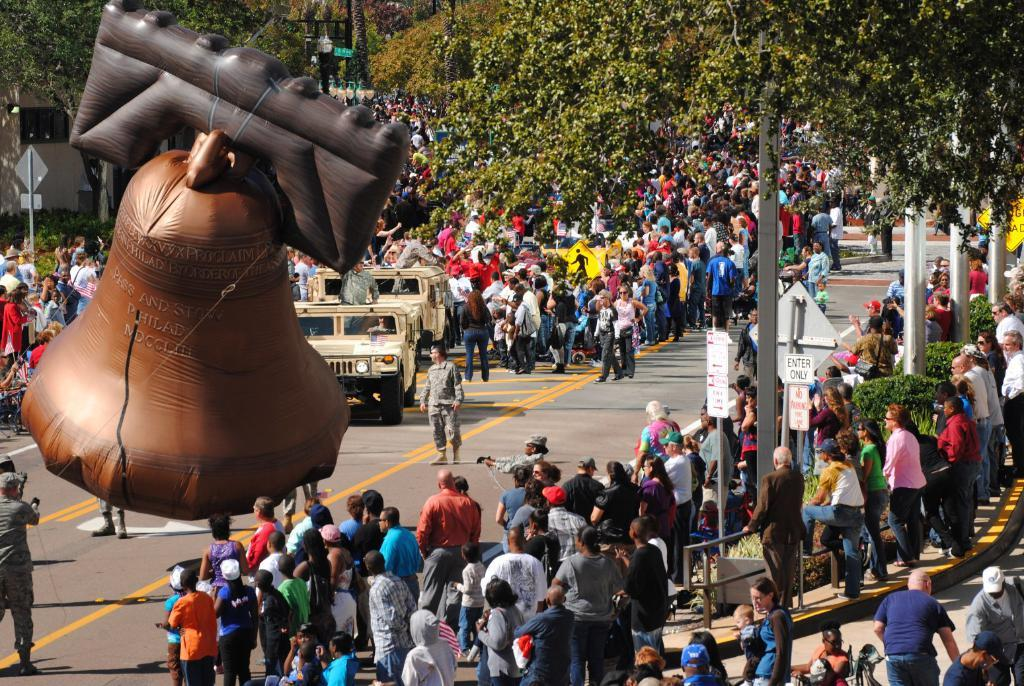How many people are in the group that is visible in the image? There is a group of people standing in the image, but the exact number cannot be determined from the provided facts. What color is the balloon bell in the image? The balloon bell in the image is brown in color. What types of vehicles can be seen in the image? Vehicles are visible in the image, but the specific types cannot be determined from the provided facts. What do the sign boards in the image indicate? The sign boards in the image provide information or directions, but the specific content cannot be determined from the provided facts. What are the poles used for in the image? The poles visible on the road in the image are likely used for traffic signals or streetlights, but their exact purpose cannot be determined from the provided facts. What type of vegetation is present in the image? Trees are present in the image, but their specific type cannot be determined from the provided facts. What type of thread is being used to hold the wall together in the image? There is no wall present in the image, so there is no thread being used to hold it together. 